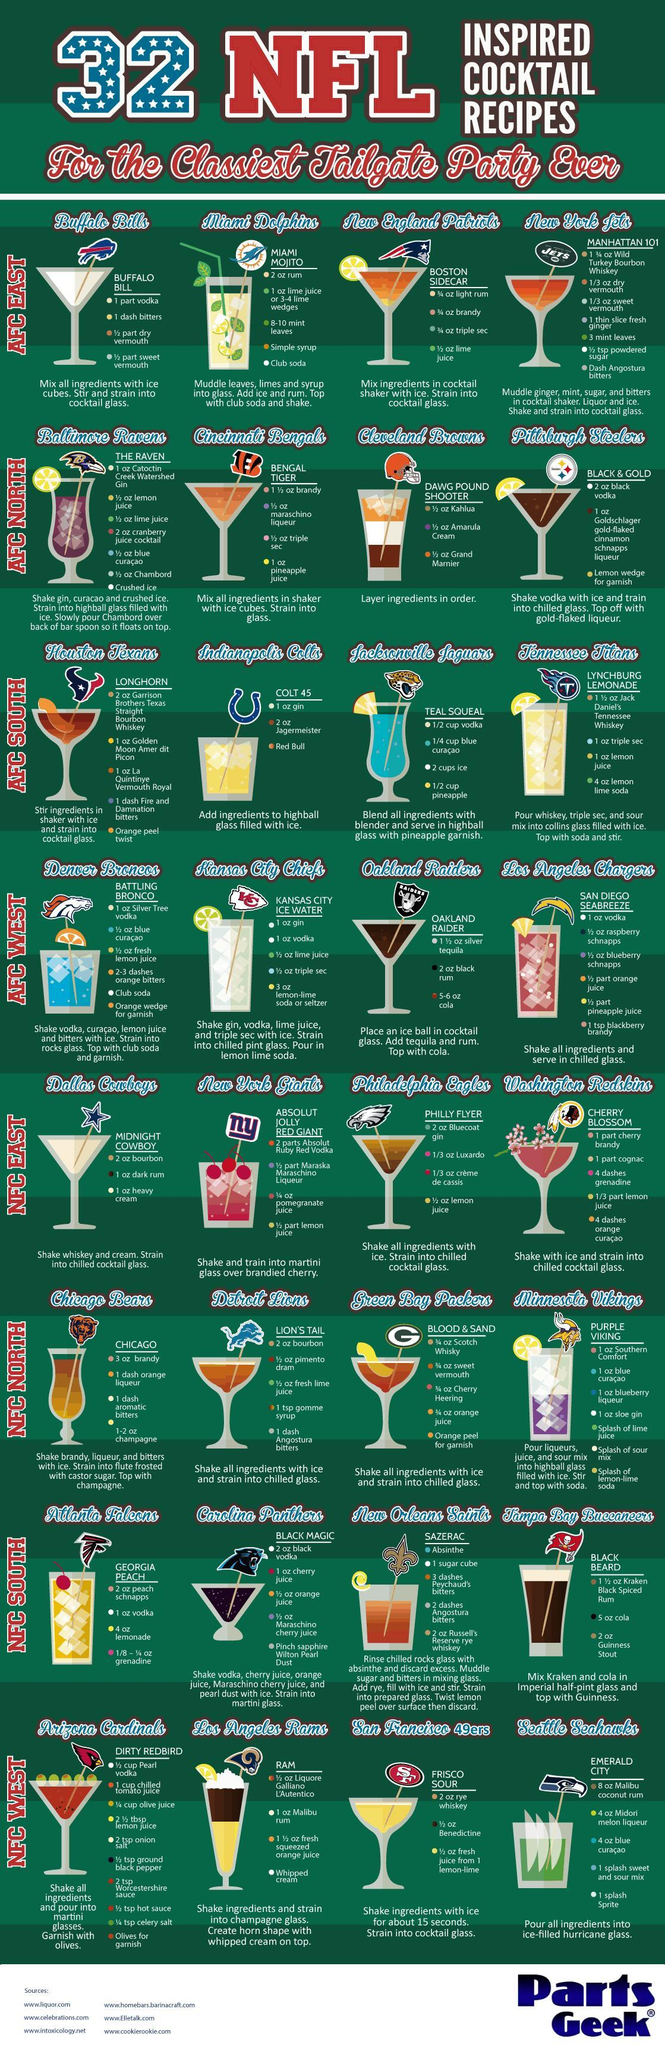How many cocktail recipes listed in AFC East contain the ingredient 'rum'?
Answer the question with a short phrase. 2 Which team has the dirty red bird recipe,  San Francisco 49ers, Seattle Seahawks or, Arizona Cardinals? Arizona Cardinals What is the name of the team that has cocktail stick with a blue and white star? Dallas Cowboys What is the name of the recipe having a cocktail stick with a blue hawk ? Emerald City How many zones is the AFC or American Football Confederation divided into? 4 How many recipes does each zone of AFC have ? 8 Which cocktail recipe in AFC North contains the ingredient pineapple juice? Bengal Tiger Which is the common ingredient in the recipes Teal Squeal and Battling Bronco? blue curacao What is the name of the cocktail that has an image of a panther ? Black Magic How many cocktails have a blue shade? 2 